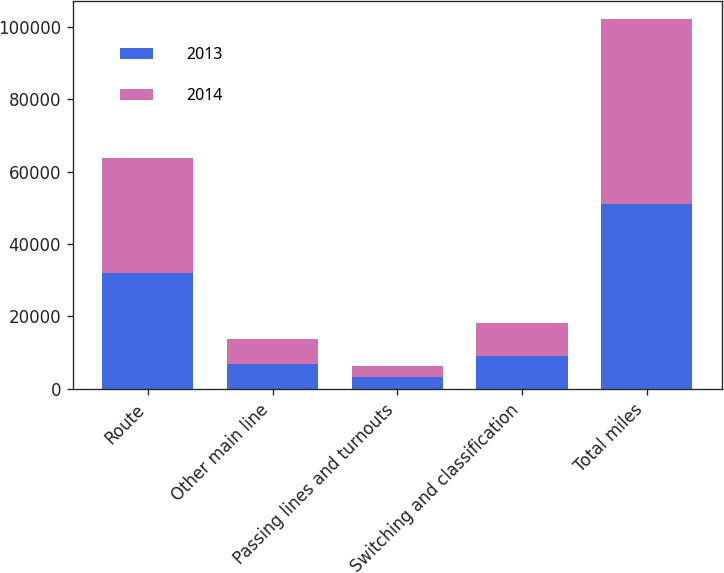Convert chart. <chart><loc_0><loc_0><loc_500><loc_500><stacked_bar_chart><ecel><fcel>Route<fcel>Other main line<fcel>Passing lines and turnouts<fcel>Switching and classification<fcel>Total miles<nl><fcel>2013<fcel>31974<fcel>6943<fcel>3197<fcel>9058<fcel>51172<nl><fcel>2014<fcel>31838<fcel>6766<fcel>3167<fcel>9090<fcel>50861<nl></chart> 